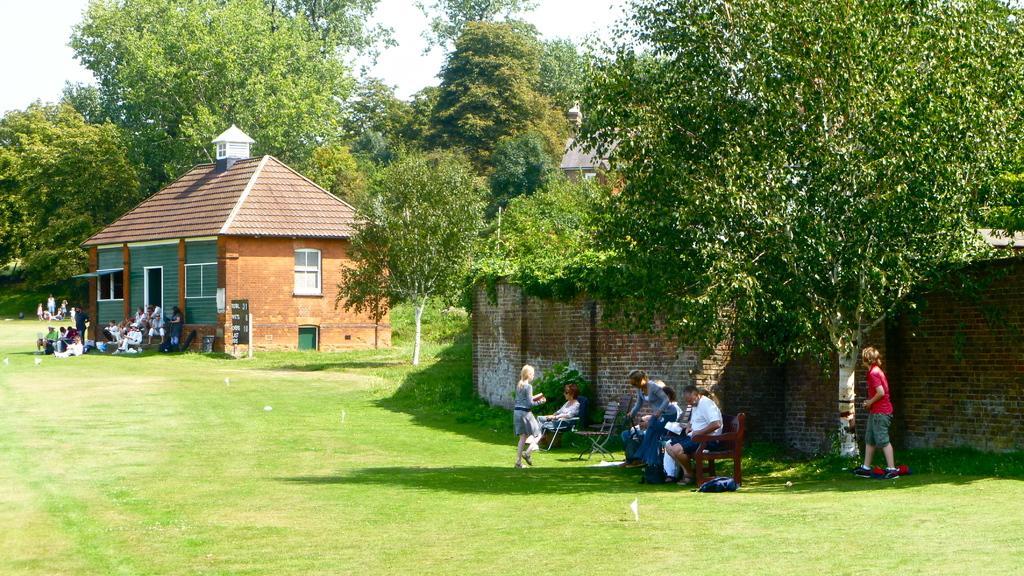Describe this image in one or two sentences. In this image there are buildings, in front of the buildings there are a few people standing and sitting on their chairs. In the background there are trees and the sky. 